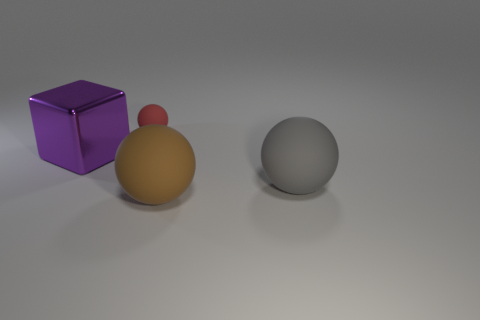Why might the orange and red spheres be attached? The orange and red spheres might be attached to demonstrate a concept in physics, like atomic structures, or simply as part of a creative design in art to contrast with the single gray sphere. Could they represent anything beyond physical objects? Certainly, they might symbolize different entities in a relationship, the interconnectedness of ideas, or elements in a system depending on the context in which they're presented. 